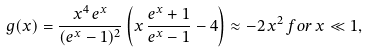<formula> <loc_0><loc_0><loc_500><loc_500>g ( x ) = \frac { x ^ { 4 } \, e ^ { x } } { ( e ^ { x } - 1 ) ^ { 2 } } \left ( x \, \frac { e ^ { x } + 1 } { e ^ { x } - 1 } - 4 \right ) \approx - 2 \, x ^ { 2 } \, f o r \, x \ll 1 ,</formula> 